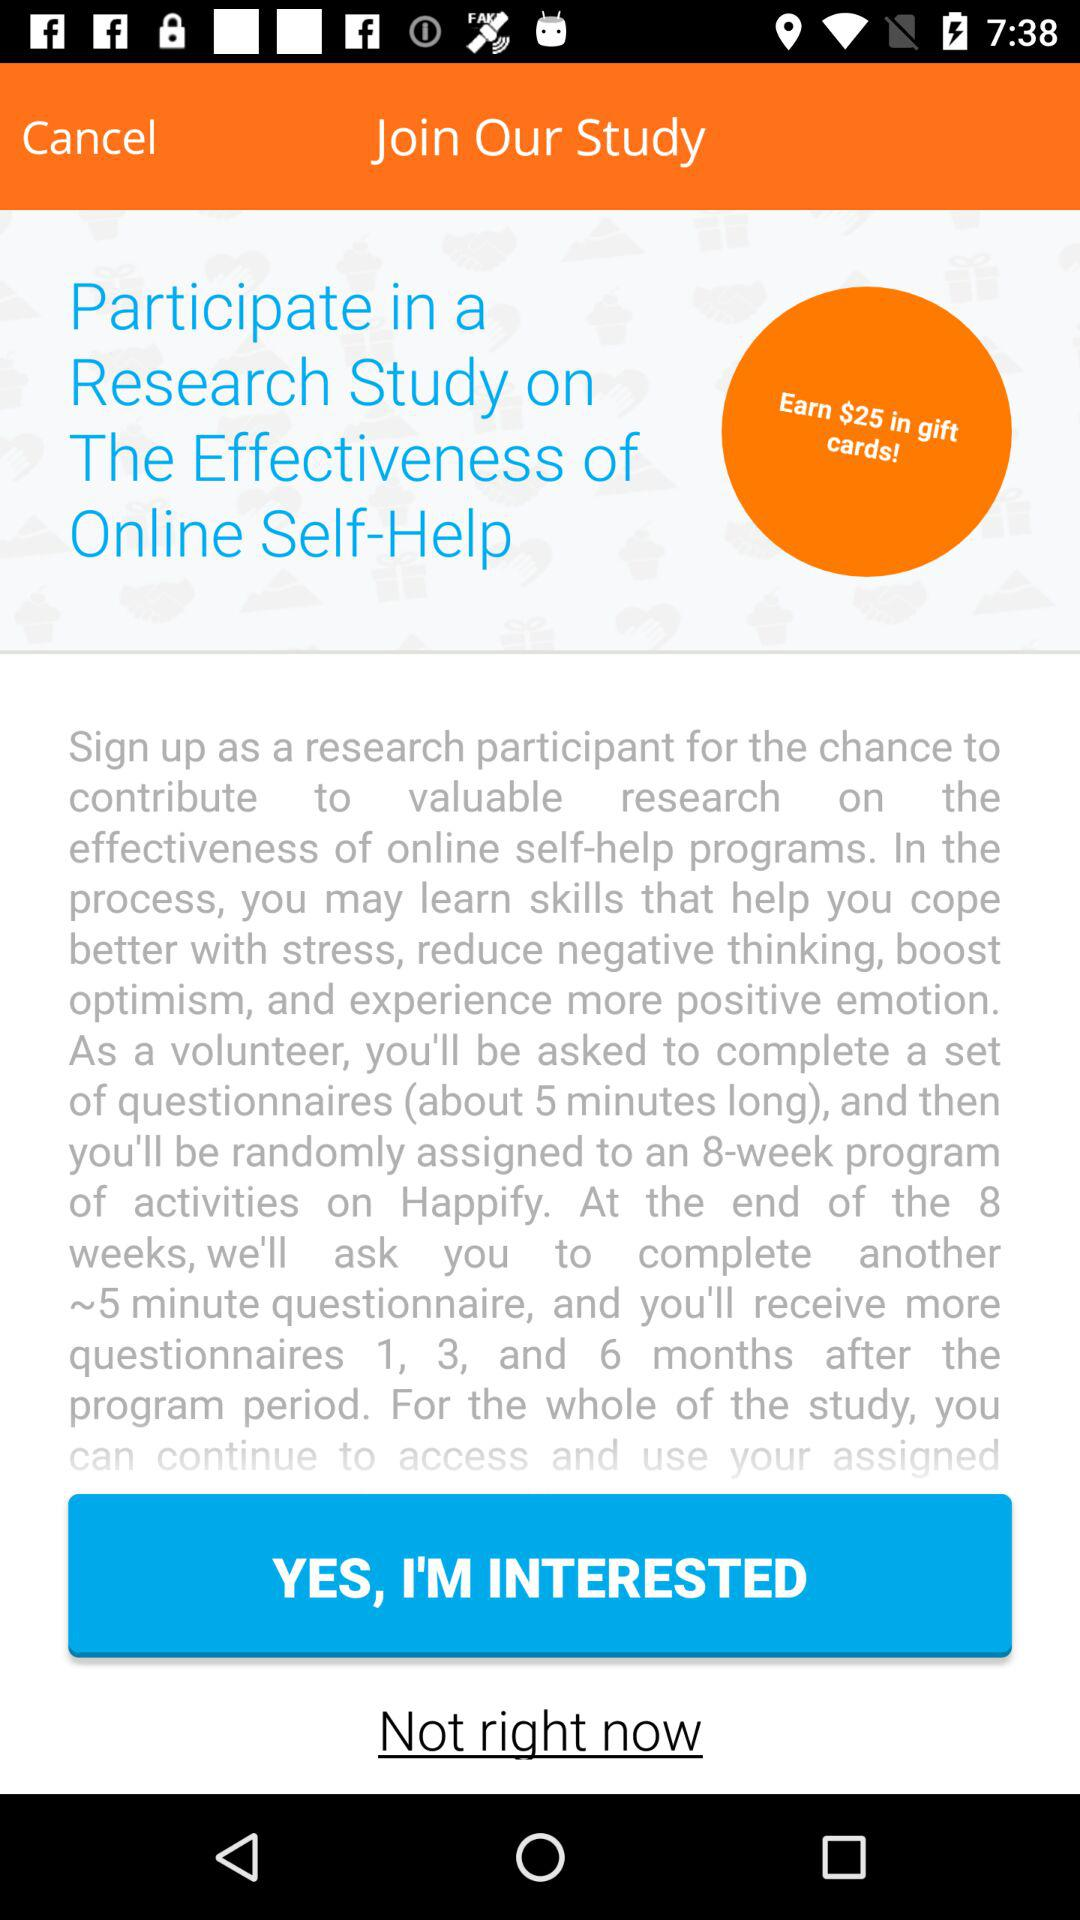What is the amount that can be earned in gift cards? The amount that can be earned in gift cards is $25. 